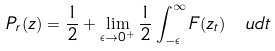<formula> <loc_0><loc_0><loc_500><loc_500>P _ { r } ( z ) = \frac { 1 } { 2 } + \lim _ { \epsilon \rightarrow 0 ^ { + } } \frac { 1 } { 2 } \int _ { - \epsilon } ^ { \infty } F ( z _ { t } ) \, \ u d t</formula> 